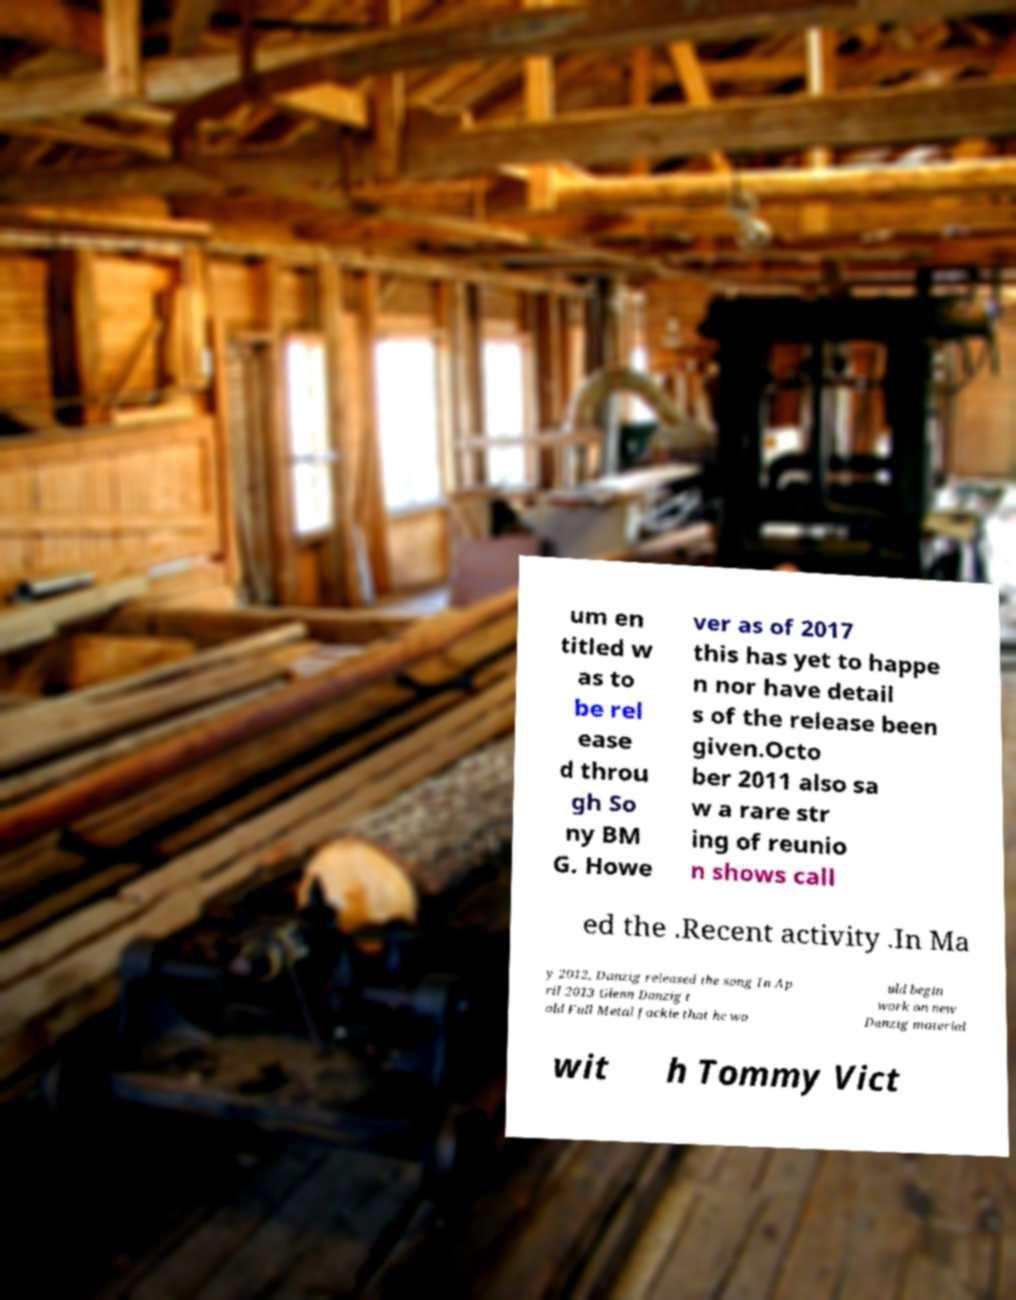What messages or text are displayed in this image? I need them in a readable, typed format. um en titled w as to be rel ease d throu gh So ny BM G. Howe ver as of 2017 this has yet to happe n nor have detail s of the release been given.Octo ber 2011 also sa w a rare str ing of reunio n shows call ed the .Recent activity .In Ma y 2012, Danzig released the song In Ap ril 2013 Glenn Danzig t old Full Metal Jackie that he wo uld begin work on new Danzig material wit h Tommy Vict 